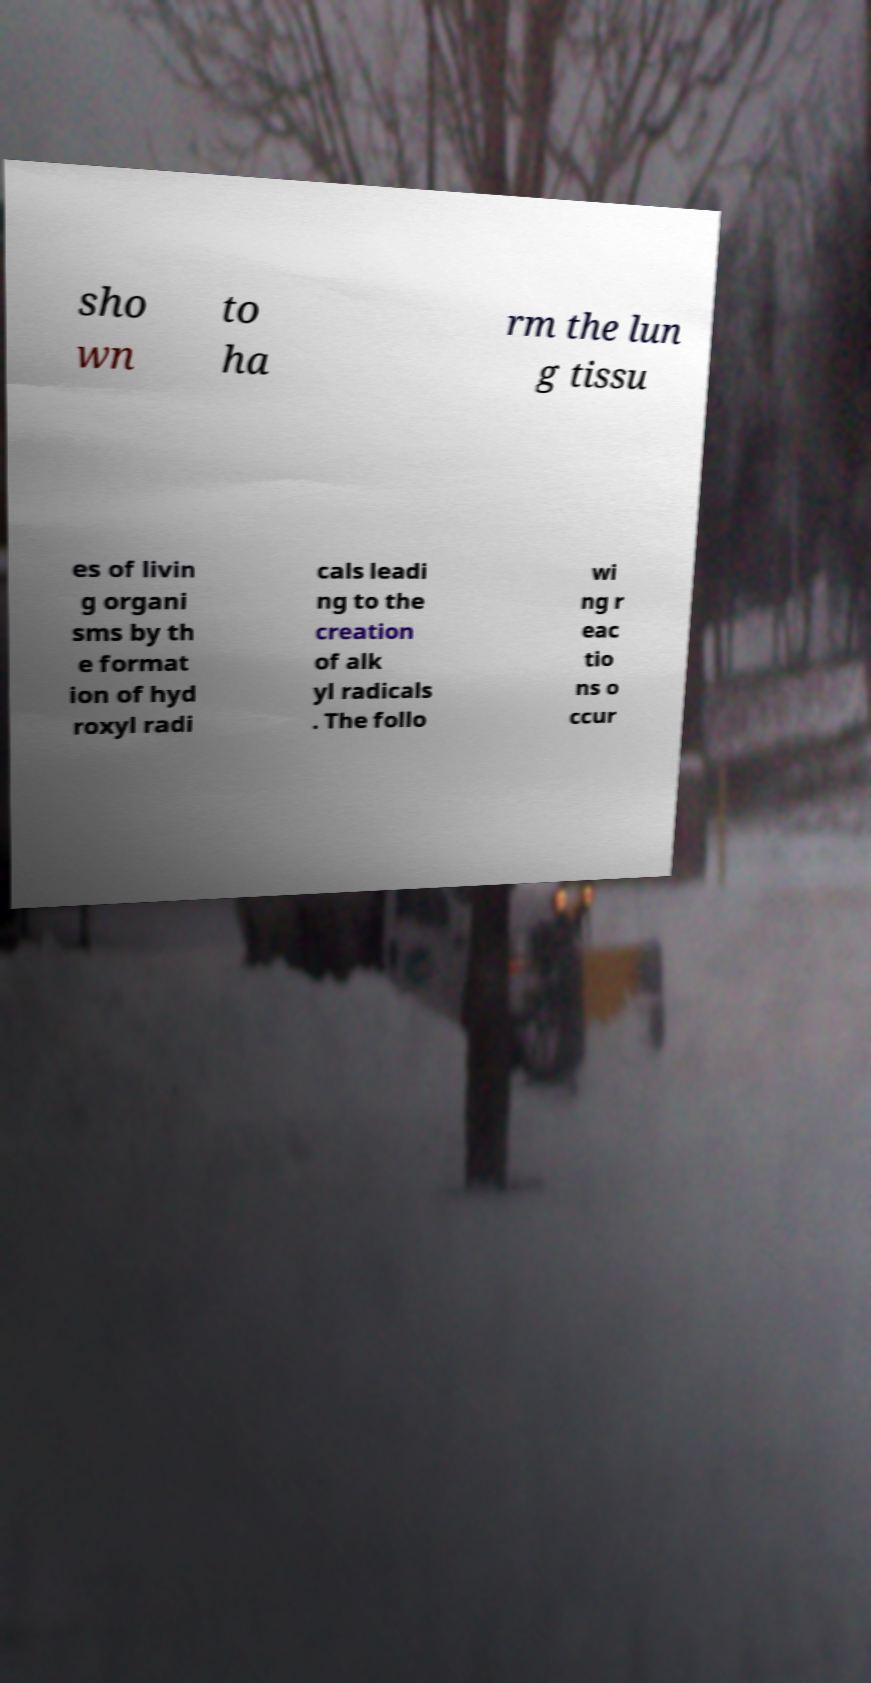Can you read and provide the text displayed in the image?This photo seems to have some interesting text. Can you extract and type it out for me? sho wn to ha rm the lun g tissu es of livin g organi sms by th e format ion of hyd roxyl radi cals leadi ng to the creation of alk yl radicals . The follo wi ng r eac tio ns o ccur 